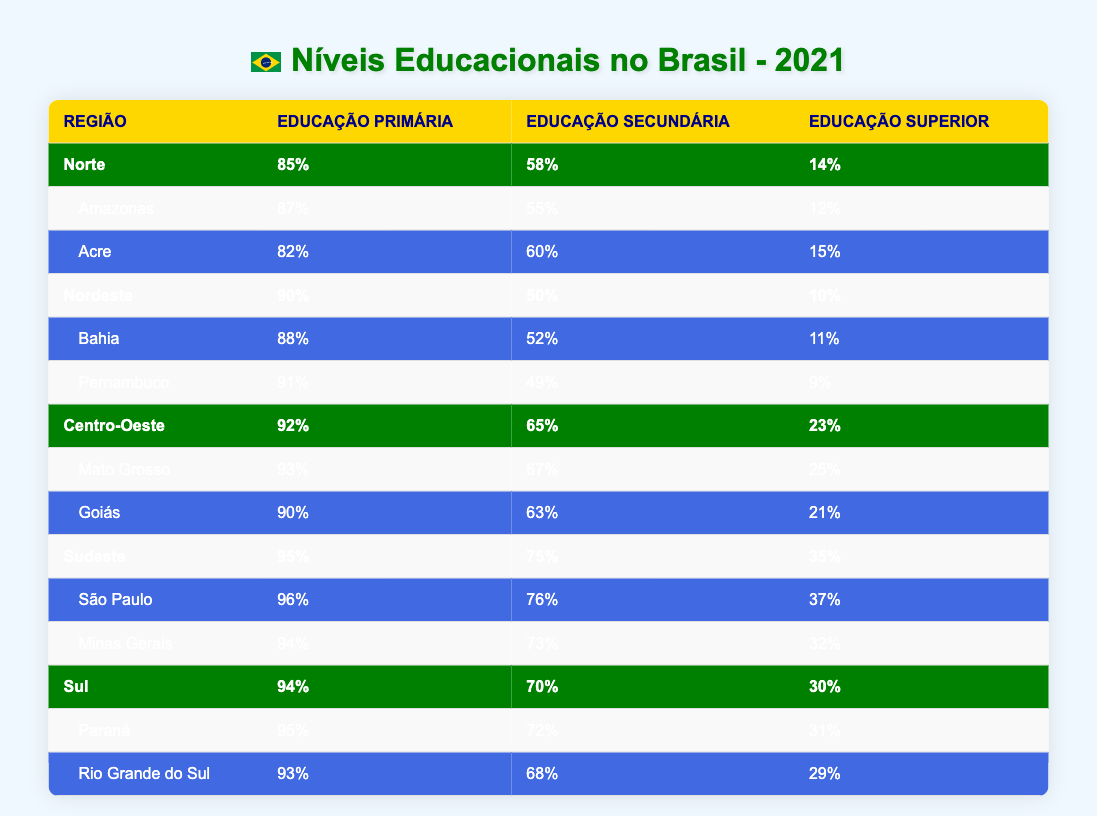What is the percentage of people with Higher Education in the Southeast region? From the table, the Southeast region shows a Higher Education attainment of 35%.
Answer: 35% Which region has the highest percentage of Primary Education attainment? The Southeast region has the highest percentage of Primary Education with 95%.
Answer: 95% Is the Secondary Education percentage in the Northeast lower than that in the North? The Northeast has 50% for Secondary Education and the North has 58%, meaning the Northeast's percentage is indeed lower.
Answer: Yes How does the Higher Education percentage of Amazonas compare to that of Goiás? Amazonas has a Higher Education percentage of 12%, while Goiás has 21%. Since 12% is less than 21%, Amazonas has a lower percentage.
Answer: Amazonas has a lower percentage What is the difference between the Primary Education percentages in the South and the Central-West? The South has 94% and the Central-West has 92%. The difference is 94% - 92% = 2%.
Answer: 2% What is the average percentage of Secondary Education across all regions? Adding the Secondary Education percentages together: 58% + 50% + 65% + 75% + 70% = 318%. Dividing by 5 regions gives an average of 318% / 5 = 63.6%.
Answer: 63.6% Does the state of Rio Grande do Sul have a higher or lower percentage of Higher Education than the national average? The national average for Higher Education in Brazil is 14%, and Rio Grande do Sul has a percentage of 29%, which is higher than the national average.
Answer: Higher Which region has the lowest percentage of Higher Education? According to the table, the Northeast region has the lowest percentage of Higher Education at 10%.
Answer: 10% What is the total percentage of Secondary Education for the two major states in the North? Summing the percentages of Secondary Education: Amazonas 55% + Acre 60% = 115%.
Answer: 115% 